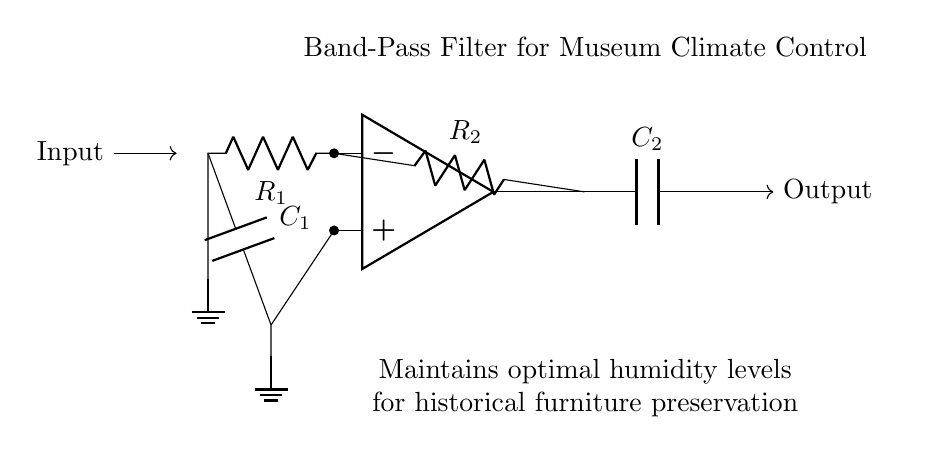What type of filter is this circuit? The circuit is identified as a band-pass filter, which allows signals within a certain frequency range to pass while attenuating frequencies outside that range. This is evident from the labeling in the circuit diagram.
Answer: band-pass filter How many capacitors are in the circuit? The circuit includes two capacitors, labeled as C1 and C2. Each is clearly drawn and labeled within the circuit diagram, allowing for easy identification.
Answer: two What components are connected to the input? The input connects to a resistor (R1) and a capacitor (C1), as shown in the circuit diagram. Each component is directly linked to the input node with specific labels.
Answer: resistor and capacitor What is the function of the op-amp in this circuit? The operational amplifier (op-amp) amplifies the voltage difference between its input terminals, which allows the band-pass filter to function properly by processing the incoming signal. This is derived from its placement in the circuit as a central component connecting various elements.
Answer: amplify What is the role of R2 in the circuit? Resistor R2 is involved in setting the gain of the operational amplifier configuration, allowing the band-pass characteristics to be defined. It affects the behavior of the filter by interacting with the op-amp, highlighting its importance in frequency response.
Answer: set gain What does C2 do in the context of this circuit? Capacitor C2 contributes to the filtering effect by allowing high-frequency signals to pass while blocking low-frequency components. This function is part of the overall band-pass filter operation, which depends on the interaction of both capacitors in the circuit.
Answer: filtering high frequencies Which connection point indicates the output of the circuit? The output of the circuit is indicated by the connection point at the rightmost part of the diagram, labeled as "Output." Its distinction as the endpoint for the processed signal makes it easily identifiable.
Answer: Output 